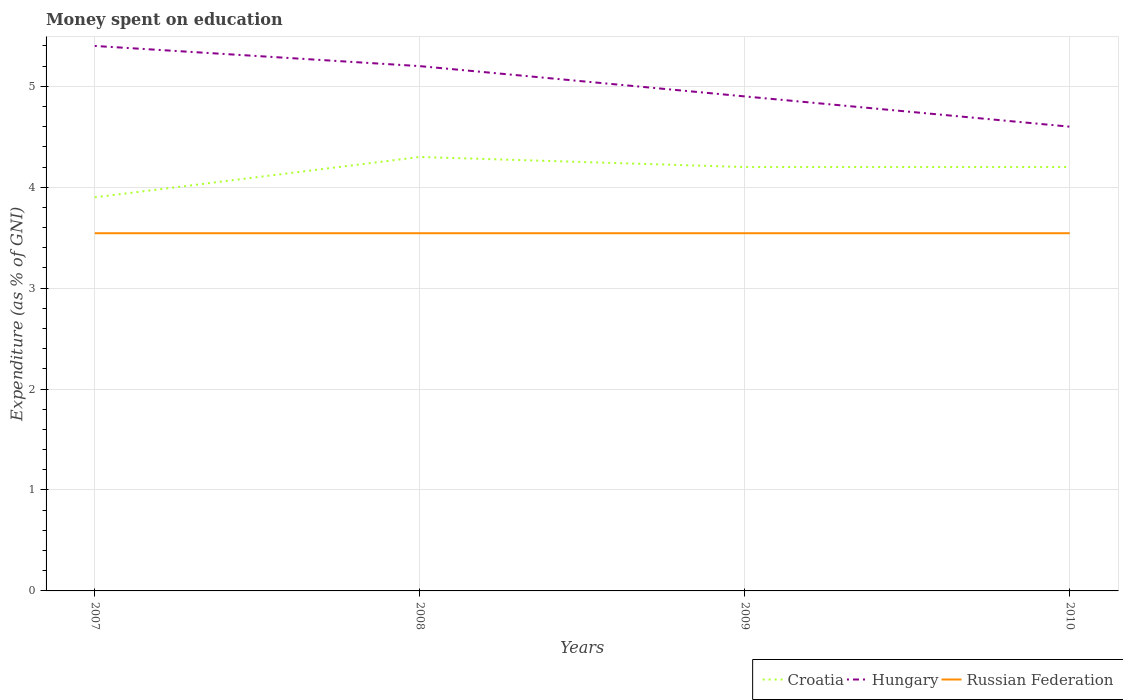How many different coloured lines are there?
Your response must be concise. 3. Is the number of lines equal to the number of legend labels?
Provide a succinct answer. Yes. In which year was the amount of money spent on education in Croatia maximum?
Provide a short and direct response. 2007. What is the total amount of money spent on education in Russian Federation in the graph?
Make the answer very short. 0. What is the difference between the highest and the second highest amount of money spent on education in Hungary?
Give a very brief answer. 0.8. Does the graph contain any zero values?
Give a very brief answer. No. Does the graph contain grids?
Make the answer very short. Yes. Where does the legend appear in the graph?
Give a very brief answer. Bottom right. How are the legend labels stacked?
Your response must be concise. Horizontal. What is the title of the graph?
Ensure brevity in your answer.  Money spent on education. Does "Isle of Man" appear as one of the legend labels in the graph?
Provide a succinct answer. No. What is the label or title of the X-axis?
Provide a short and direct response. Years. What is the label or title of the Y-axis?
Offer a very short reply. Expenditure (as % of GNI). What is the Expenditure (as % of GNI) of Russian Federation in 2007?
Give a very brief answer. 3.54. What is the Expenditure (as % of GNI) of Croatia in 2008?
Offer a very short reply. 4.3. What is the Expenditure (as % of GNI) of Hungary in 2008?
Your response must be concise. 5.2. What is the Expenditure (as % of GNI) of Russian Federation in 2008?
Provide a succinct answer. 3.54. What is the Expenditure (as % of GNI) in Croatia in 2009?
Give a very brief answer. 4.2. What is the Expenditure (as % of GNI) in Hungary in 2009?
Keep it short and to the point. 4.9. What is the Expenditure (as % of GNI) of Russian Federation in 2009?
Offer a terse response. 3.54. What is the Expenditure (as % of GNI) in Hungary in 2010?
Give a very brief answer. 4.6. What is the Expenditure (as % of GNI) of Russian Federation in 2010?
Your answer should be very brief. 3.54. Across all years, what is the maximum Expenditure (as % of GNI) in Croatia?
Your answer should be compact. 4.3. Across all years, what is the maximum Expenditure (as % of GNI) in Hungary?
Give a very brief answer. 5.4. Across all years, what is the maximum Expenditure (as % of GNI) in Russian Federation?
Offer a very short reply. 3.54. Across all years, what is the minimum Expenditure (as % of GNI) of Hungary?
Ensure brevity in your answer.  4.6. Across all years, what is the minimum Expenditure (as % of GNI) of Russian Federation?
Give a very brief answer. 3.54. What is the total Expenditure (as % of GNI) of Hungary in the graph?
Provide a short and direct response. 20.1. What is the total Expenditure (as % of GNI) of Russian Federation in the graph?
Provide a short and direct response. 14.18. What is the difference between the Expenditure (as % of GNI) of Croatia in 2007 and that in 2008?
Offer a terse response. -0.4. What is the difference between the Expenditure (as % of GNI) in Hungary in 2007 and that in 2008?
Offer a very short reply. 0.2. What is the difference between the Expenditure (as % of GNI) of Russian Federation in 2007 and that in 2008?
Keep it short and to the point. 0. What is the difference between the Expenditure (as % of GNI) of Croatia in 2007 and that in 2009?
Keep it short and to the point. -0.3. What is the difference between the Expenditure (as % of GNI) in Hungary in 2007 and that in 2009?
Provide a short and direct response. 0.5. What is the difference between the Expenditure (as % of GNI) of Russian Federation in 2007 and that in 2009?
Ensure brevity in your answer.  0. What is the difference between the Expenditure (as % of GNI) of Croatia in 2007 and that in 2010?
Your response must be concise. -0.3. What is the difference between the Expenditure (as % of GNI) in Hungary in 2007 and that in 2010?
Provide a short and direct response. 0.8. What is the difference between the Expenditure (as % of GNI) in Croatia in 2008 and that in 2009?
Give a very brief answer. 0.1. What is the difference between the Expenditure (as % of GNI) in Russian Federation in 2008 and that in 2009?
Your response must be concise. 0. What is the difference between the Expenditure (as % of GNI) of Hungary in 2008 and that in 2010?
Provide a succinct answer. 0.6. What is the difference between the Expenditure (as % of GNI) of Russian Federation in 2008 and that in 2010?
Your response must be concise. 0. What is the difference between the Expenditure (as % of GNI) in Hungary in 2009 and that in 2010?
Make the answer very short. 0.3. What is the difference between the Expenditure (as % of GNI) in Russian Federation in 2009 and that in 2010?
Your response must be concise. 0. What is the difference between the Expenditure (as % of GNI) in Croatia in 2007 and the Expenditure (as % of GNI) in Hungary in 2008?
Offer a terse response. -1.3. What is the difference between the Expenditure (as % of GNI) in Croatia in 2007 and the Expenditure (as % of GNI) in Russian Federation in 2008?
Keep it short and to the point. 0.36. What is the difference between the Expenditure (as % of GNI) in Hungary in 2007 and the Expenditure (as % of GNI) in Russian Federation in 2008?
Your answer should be compact. 1.86. What is the difference between the Expenditure (as % of GNI) in Croatia in 2007 and the Expenditure (as % of GNI) in Russian Federation in 2009?
Your answer should be very brief. 0.36. What is the difference between the Expenditure (as % of GNI) in Hungary in 2007 and the Expenditure (as % of GNI) in Russian Federation in 2009?
Your answer should be very brief. 1.86. What is the difference between the Expenditure (as % of GNI) of Croatia in 2007 and the Expenditure (as % of GNI) of Russian Federation in 2010?
Ensure brevity in your answer.  0.36. What is the difference between the Expenditure (as % of GNI) in Hungary in 2007 and the Expenditure (as % of GNI) in Russian Federation in 2010?
Your answer should be compact. 1.86. What is the difference between the Expenditure (as % of GNI) in Croatia in 2008 and the Expenditure (as % of GNI) in Hungary in 2009?
Provide a short and direct response. -0.6. What is the difference between the Expenditure (as % of GNI) in Croatia in 2008 and the Expenditure (as % of GNI) in Russian Federation in 2009?
Offer a very short reply. 0.76. What is the difference between the Expenditure (as % of GNI) of Hungary in 2008 and the Expenditure (as % of GNI) of Russian Federation in 2009?
Your response must be concise. 1.66. What is the difference between the Expenditure (as % of GNI) in Croatia in 2008 and the Expenditure (as % of GNI) in Hungary in 2010?
Keep it short and to the point. -0.3. What is the difference between the Expenditure (as % of GNI) in Croatia in 2008 and the Expenditure (as % of GNI) in Russian Federation in 2010?
Your response must be concise. 0.76. What is the difference between the Expenditure (as % of GNI) in Hungary in 2008 and the Expenditure (as % of GNI) in Russian Federation in 2010?
Your answer should be very brief. 1.66. What is the difference between the Expenditure (as % of GNI) of Croatia in 2009 and the Expenditure (as % of GNI) of Russian Federation in 2010?
Offer a terse response. 0.66. What is the difference between the Expenditure (as % of GNI) in Hungary in 2009 and the Expenditure (as % of GNI) in Russian Federation in 2010?
Make the answer very short. 1.36. What is the average Expenditure (as % of GNI) in Croatia per year?
Provide a short and direct response. 4.15. What is the average Expenditure (as % of GNI) of Hungary per year?
Your answer should be very brief. 5.03. What is the average Expenditure (as % of GNI) in Russian Federation per year?
Your answer should be compact. 3.54. In the year 2007, what is the difference between the Expenditure (as % of GNI) in Croatia and Expenditure (as % of GNI) in Russian Federation?
Your answer should be compact. 0.36. In the year 2007, what is the difference between the Expenditure (as % of GNI) in Hungary and Expenditure (as % of GNI) in Russian Federation?
Give a very brief answer. 1.86. In the year 2008, what is the difference between the Expenditure (as % of GNI) in Croatia and Expenditure (as % of GNI) in Hungary?
Offer a very short reply. -0.9. In the year 2008, what is the difference between the Expenditure (as % of GNI) in Croatia and Expenditure (as % of GNI) in Russian Federation?
Your response must be concise. 0.76. In the year 2008, what is the difference between the Expenditure (as % of GNI) in Hungary and Expenditure (as % of GNI) in Russian Federation?
Your response must be concise. 1.66. In the year 2009, what is the difference between the Expenditure (as % of GNI) of Croatia and Expenditure (as % of GNI) of Hungary?
Your answer should be compact. -0.7. In the year 2009, what is the difference between the Expenditure (as % of GNI) of Croatia and Expenditure (as % of GNI) of Russian Federation?
Your response must be concise. 0.66. In the year 2009, what is the difference between the Expenditure (as % of GNI) of Hungary and Expenditure (as % of GNI) of Russian Federation?
Offer a terse response. 1.36. In the year 2010, what is the difference between the Expenditure (as % of GNI) in Croatia and Expenditure (as % of GNI) in Hungary?
Provide a succinct answer. -0.4. In the year 2010, what is the difference between the Expenditure (as % of GNI) in Croatia and Expenditure (as % of GNI) in Russian Federation?
Make the answer very short. 0.66. In the year 2010, what is the difference between the Expenditure (as % of GNI) in Hungary and Expenditure (as % of GNI) in Russian Federation?
Your response must be concise. 1.06. What is the ratio of the Expenditure (as % of GNI) of Croatia in 2007 to that in 2008?
Provide a succinct answer. 0.91. What is the ratio of the Expenditure (as % of GNI) of Russian Federation in 2007 to that in 2008?
Ensure brevity in your answer.  1. What is the ratio of the Expenditure (as % of GNI) of Croatia in 2007 to that in 2009?
Give a very brief answer. 0.93. What is the ratio of the Expenditure (as % of GNI) in Hungary in 2007 to that in 2009?
Provide a succinct answer. 1.1. What is the ratio of the Expenditure (as % of GNI) in Hungary in 2007 to that in 2010?
Provide a short and direct response. 1.17. What is the ratio of the Expenditure (as % of GNI) of Croatia in 2008 to that in 2009?
Ensure brevity in your answer.  1.02. What is the ratio of the Expenditure (as % of GNI) in Hungary in 2008 to that in 2009?
Your answer should be compact. 1.06. What is the ratio of the Expenditure (as % of GNI) in Croatia in 2008 to that in 2010?
Your answer should be very brief. 1.02. What is the ratio of the Expenditure (as % of GNI) of Hungary in 2008 to that in 2010?
Offer a terse response. 1.13. What is the ratio of the Expenditure (as % of GNI) of Russian Federation in 2008 to that in 2010?
Ensure brevity in your answer.  1. What is the ratio of the Expenditure (as % of GNI) in Hungary in 2009 to that in 2010?
Ensure brevity in your answer.  1.07. What is the difference between the highest and the second highest Expenditure (as % of GNI) in Hungary?
Make the answer very short. 0.2. What is the difference between the highest and the lowest Expenditure (as % of GNI) of Croatia?
Keep it short and to the point. 0.4. What is the difference between the highest and the lowest Expenditure (as % of GNI) of Hungary?
Offer a very short reply. 0.8. 